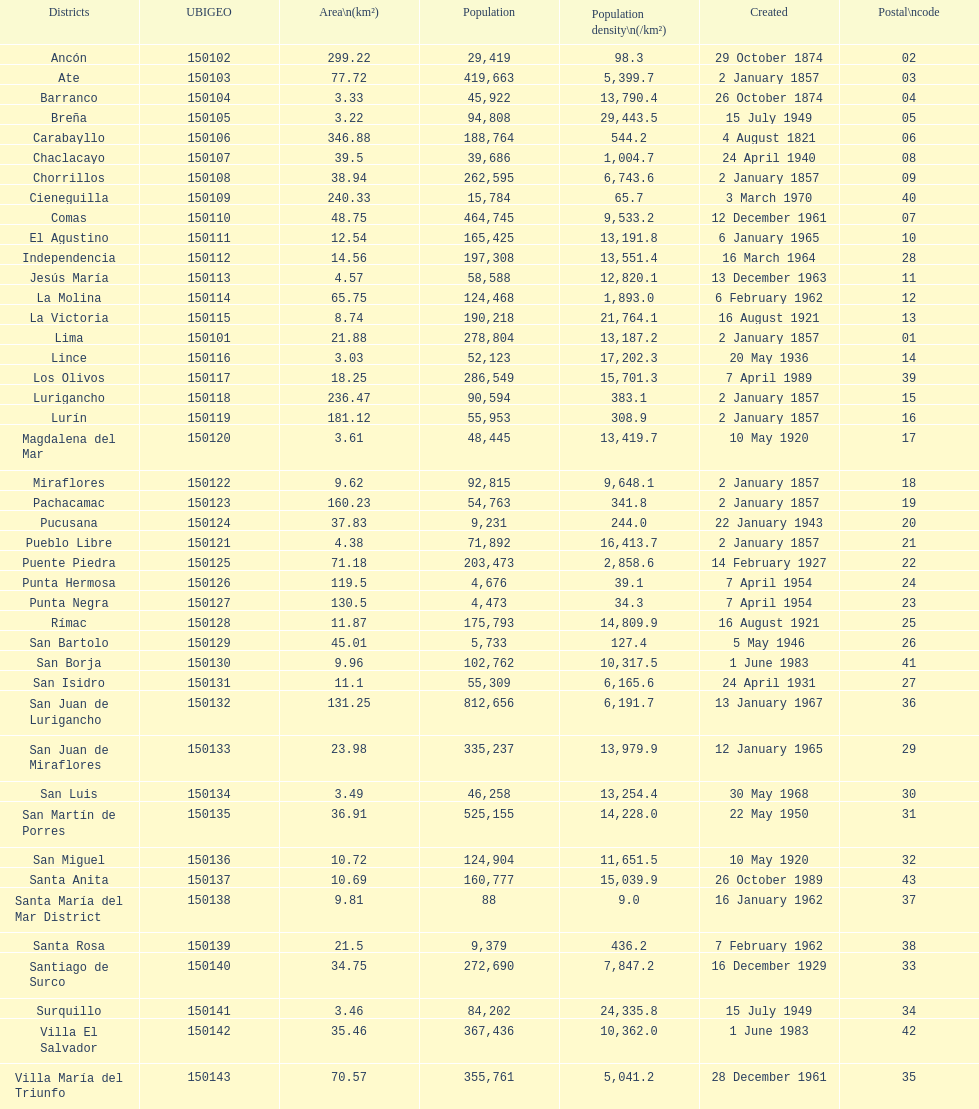In how many districts is the population density at least 100 31. 